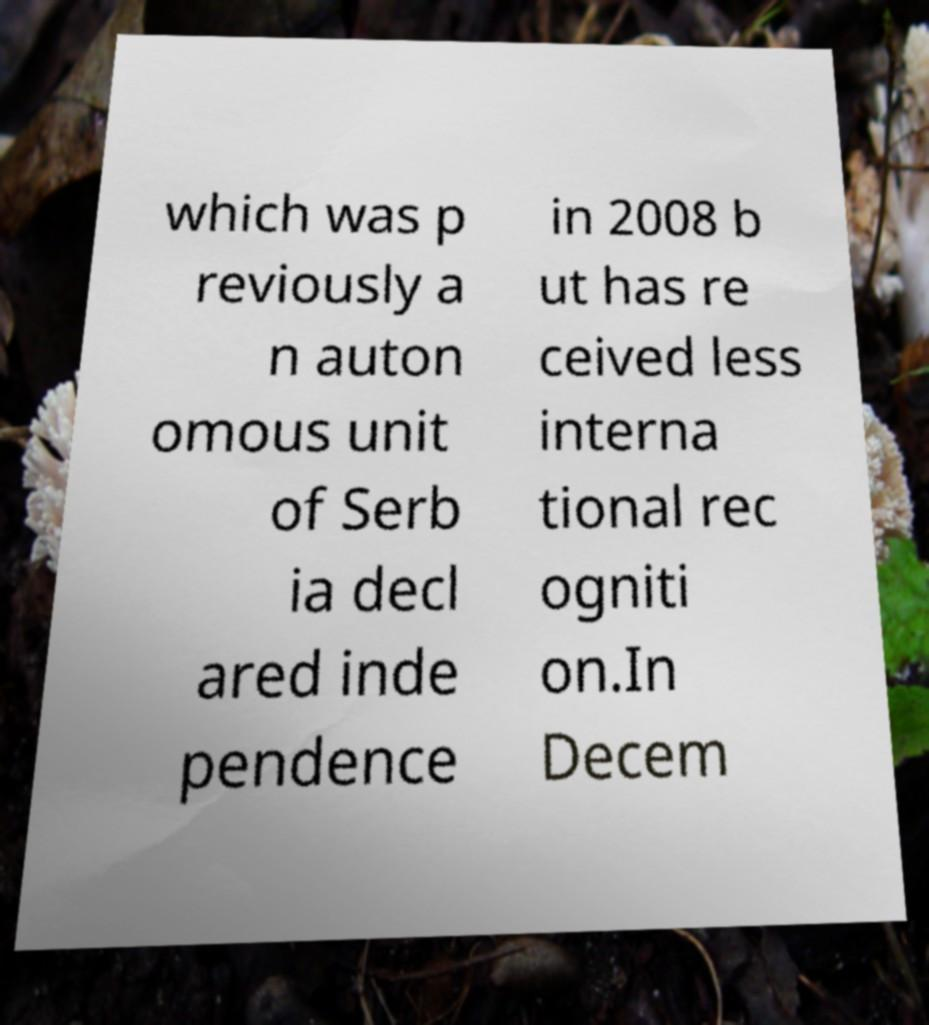Please read and relay the text visible in this image. What does it say? which was p reviously a n auton omous unit of Serb ia decl ared inde pendence in 2008 b ut has re ceived less interna tional rec ogniti on.In Decem 